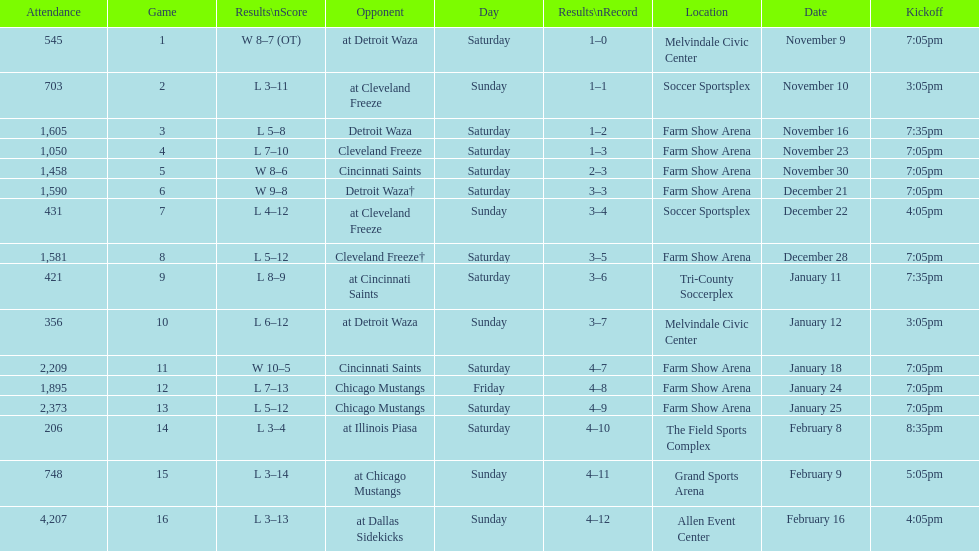What was the location before tri-county soccerplex? Farm Show Arena. 